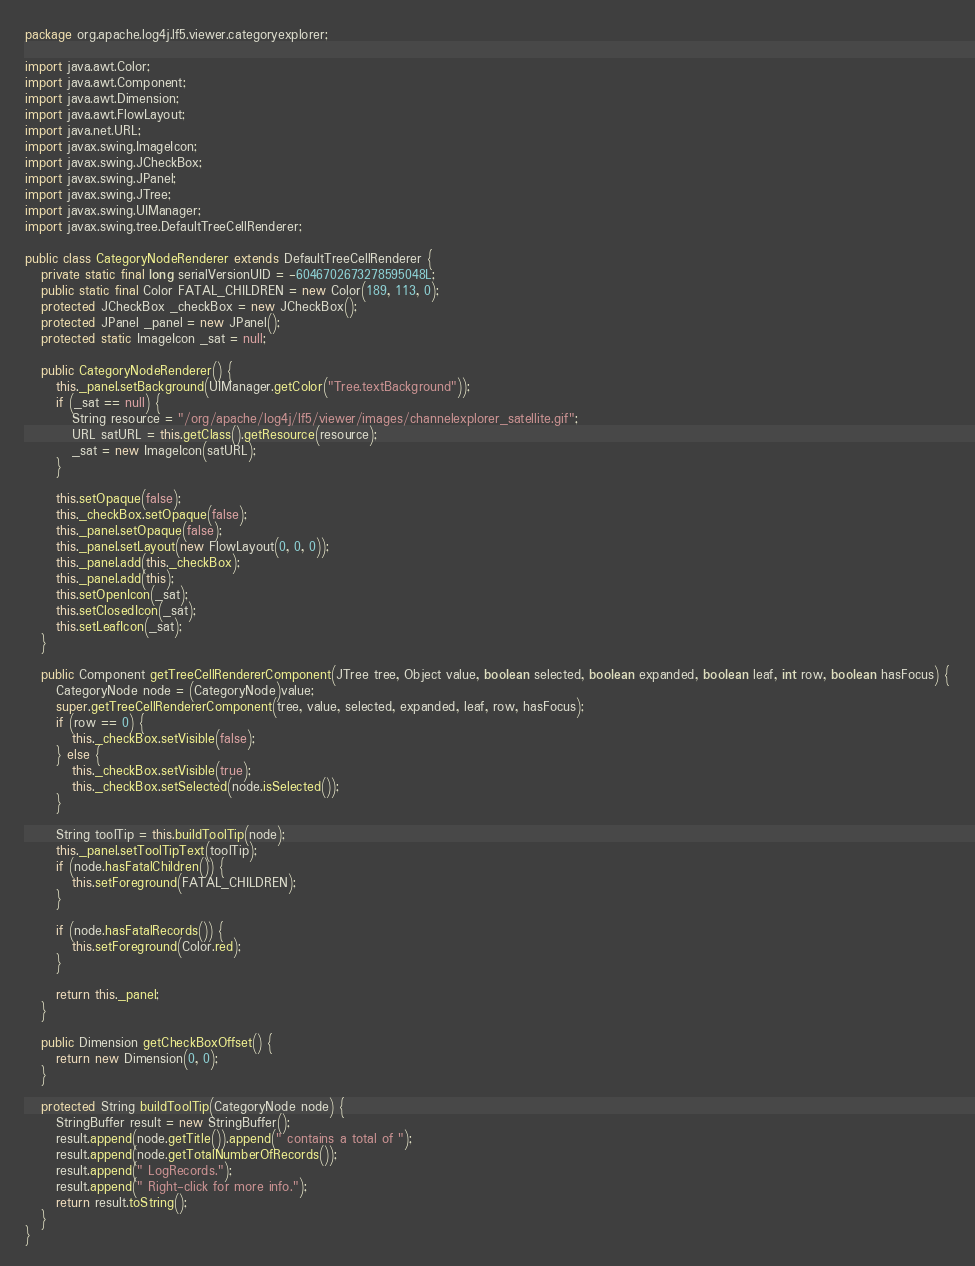<code> <loc_0><loc_0><loc_500><loc_500><_Java_>package org.apache.log4j.lf5.viewer.categoryexplorer;

import java.awt.Color;
import java.awt.Component;
import java.awt.Dimension;
import java.awt.FlowLayout;
import java.net.URL;
import javax.swing.ImageIcon;
import javax.swing.JCheckBox;
import javax.swing.JPanel;
import javax.swing.JTree;
import javax.swing.UIManager;
import javax.swing.tree.DefaultTreeCellRenderer;

public class CategoryNodeRenderer extends DefaultTreeCellRenderer {
   private static final long serialVersionUID = -6046702673278595048L;
   public static final Color FATAL_CHILDREN = new Color(189, 113, 0);
   protected JCheckBox _checkBox = new JCheckBox();
   protected JPanel _panel = new JPanel();
   protected static ImageIcon _sat = null;

   public CategoryNodeRenderer() {
      this._panel.setBackground(UIManager.getColor("Tree.textBackground"));
      if (_sat == null) {
         String resource = "/org/apache/log4j/lf5/viewer/images/channelexplorer_satellite.gif";
         URL satURL = this.getClass().getResource(resource);
         _sat = new ImageIcon(satURL);
      }

      this.setOpaque(false);
      this._checkBox.setOpaque(false);
      this._panel.setOpaque(false);
      this._panel.setLayout(new FlowLayout(0, 0, 0));
      this._panel.add(this._checkBox);
      this._panel.add(this);
      this.setOpenIcon(_sat);
      this.setClosedIcon(_sat);
      this.setLeafIcon(_sat);
   }

   public Component getTreeCellRendererComponent(JTree tree, Object value, boolean selected, boolean expanded, boolean leaf, int row, boolean hasFocus) {
      CategoryNode node = (CategoryNode)value;
      super.getTreeCellRendererComponent(tree, value, selected, expanded, leaf, row, hasFocus);
      if (row == 0) {
         this._checkBox.setVisible(false);
      } else {
         this._checkBox.setVisible(true);
         this._checkBox.setSelected(node.isSelected());
      }

      String toolTip = this.buildToolTip(node);
      this._panel.setToolTipText(toolTip);
      if (node.hasFatalChildren()) {
         this.setForeground(FATAL_CHILDREN);
      }

      if (node.hasFatalRecords()) {
         this.setForeground(Color.red);
      }

      return this._panel;
   }

   public Dimension getCheckBoxOffset() {
      return new Dimension(0, 0);
   }

   protected String buildToolTip(CategoryNode node) {
      StringBuffer result = new StringBuffer();
      result.append(node.getTitle()).append(" contains a total of ");
      result.append(node.getTotalNumberOfRecords());
      result.append(" LogRecords.");
      result.append(" Right-click for more info.");
      return result.toString();
   }
}
</code> 